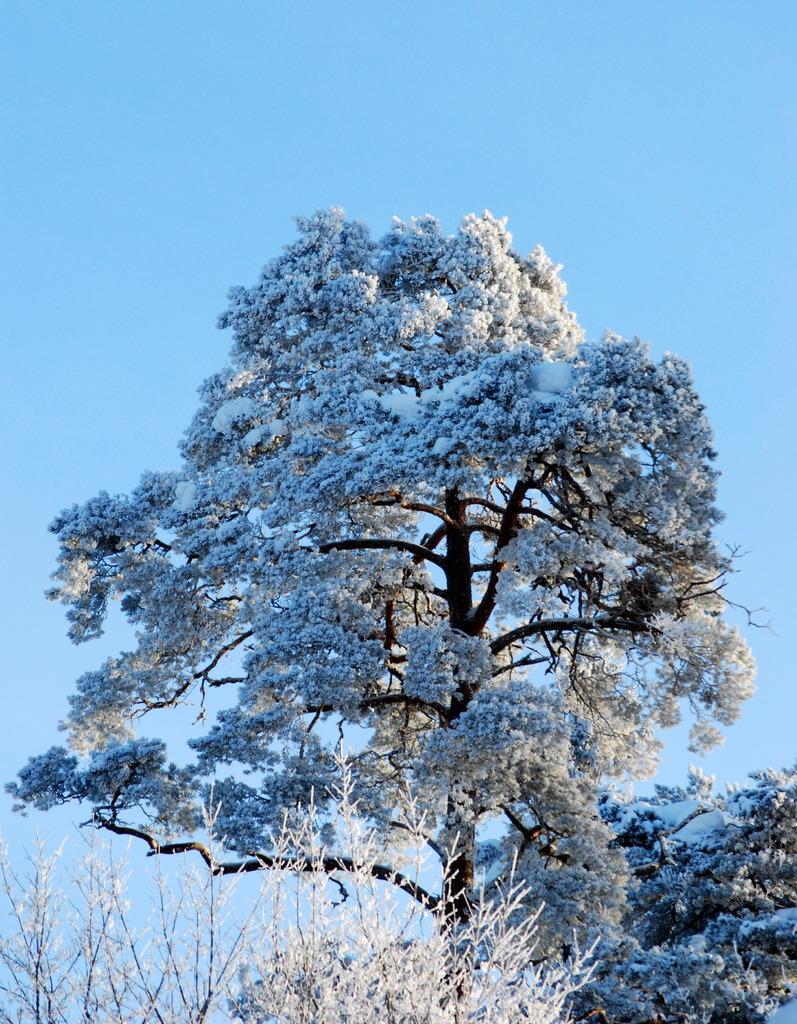Describe this image in one or two sentences. In this image we can see trees and plants. On the plants and trees we can see the snow. Behind the trees we can see the sky. 